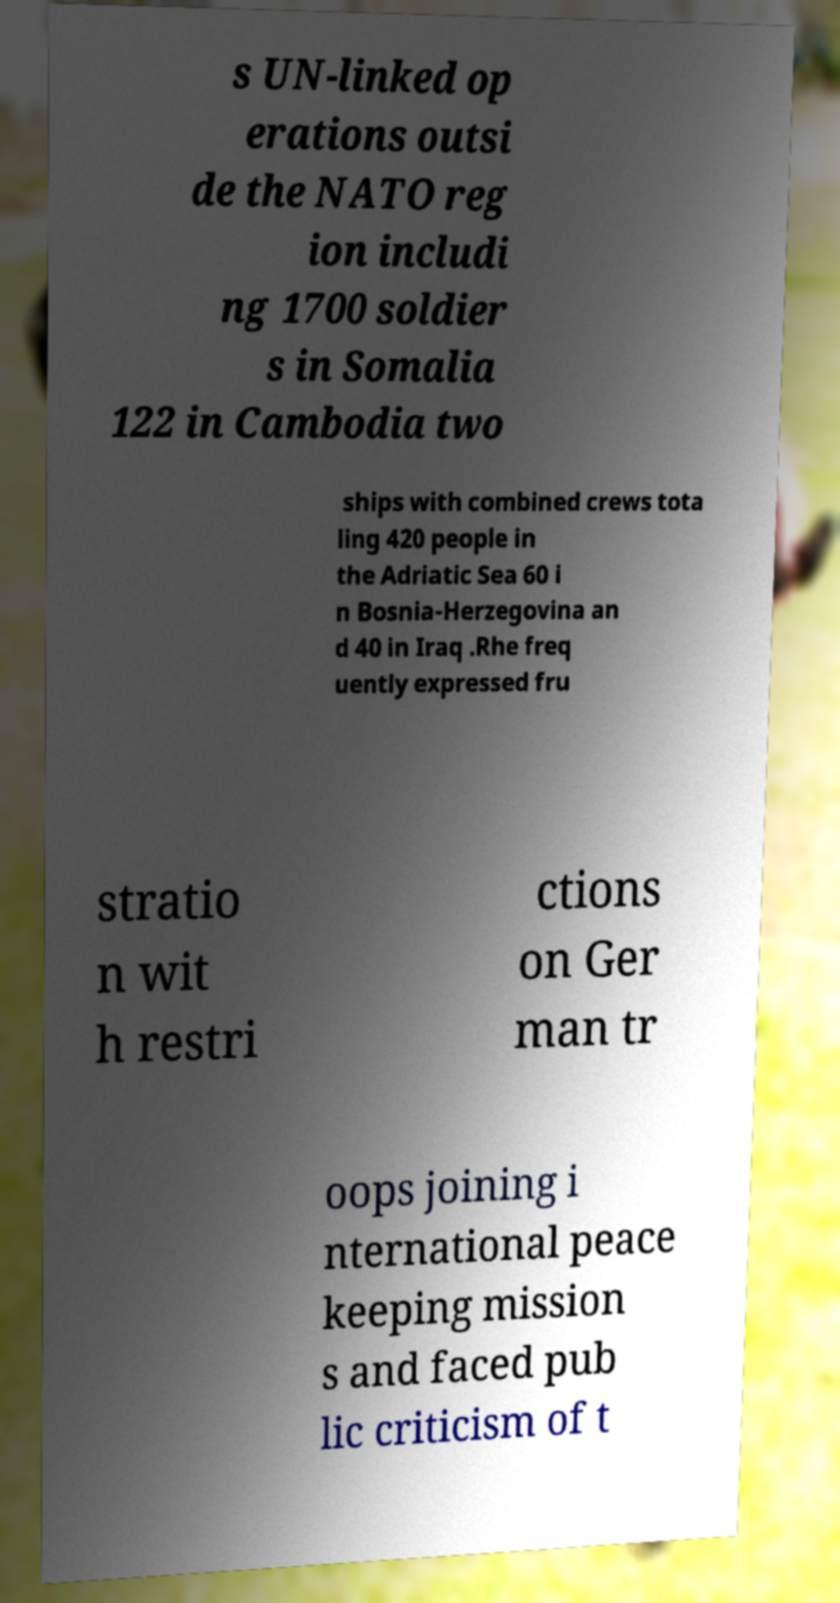Please identify and transcribe the text found in this image. s UN-linked op erations outsi de the NATO reg ion includi ng 1700 soldier s in Somalia 122 in Cambodia two ships with combined crews tota ling 420 people in the Adriatic Sea 60 i n Bosnia-Herzegovina an d 40 in Iraq .Rhe freq uently expressed fru stratio n wit h restri ctions on Ger man tr oops joining i nternational peace keeping mission s and faced pub lic criticism of t 